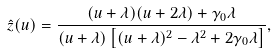<formula> <loc_0><loc_0><loc_500><loc_500>\hat { z } ( u ) = \frac { ( u + \lambda ) ( u + 2 \lambda ) + \gamma _ { 0 } \lambda } { ( u + \lambda ) \left [ ( u + \lambda ) ^ { 2 } - \lambda ^ { 2 } + 2 \gamma _ { 0 } \lambda \right ] } ,</formula> 